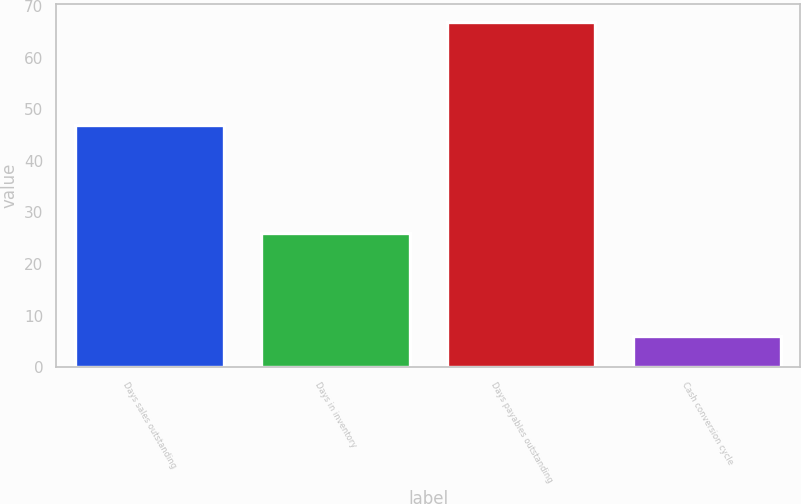Convert chart. <chart><loc_0><loc_0><loc_500><loc_500><bar_chart><fcel>Days sales outstanding<fcel>Days in inventory<fcel>Days payables outstanding<fcel>Cash conversion cycle<nl><fcel>47<fcel>26<fcel>67<fcel>6<nl></chart> 